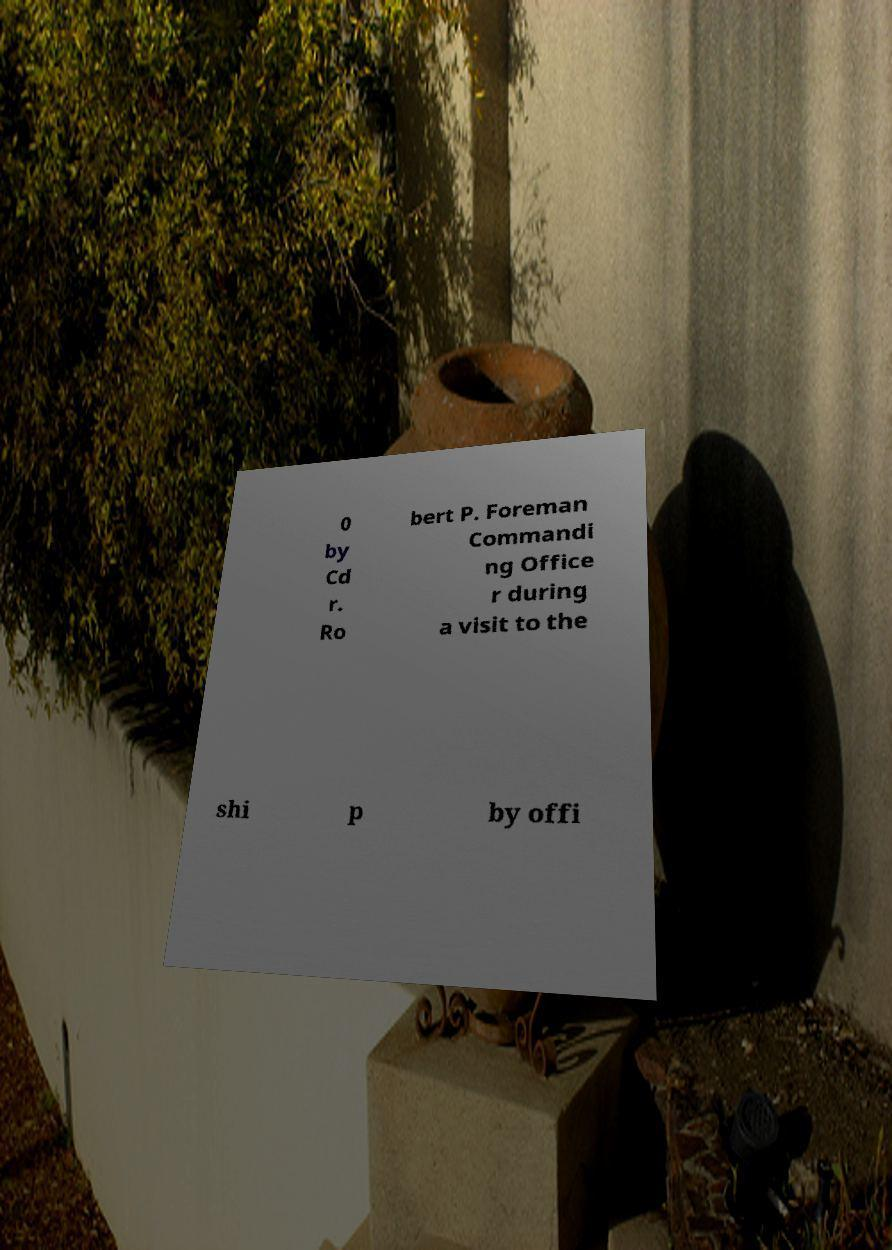Please identify and transcribe the text found in this image. 0 by Cd r. Ro bert P. Foreman Commandi ng Office r during a visit to the shi p by offi 